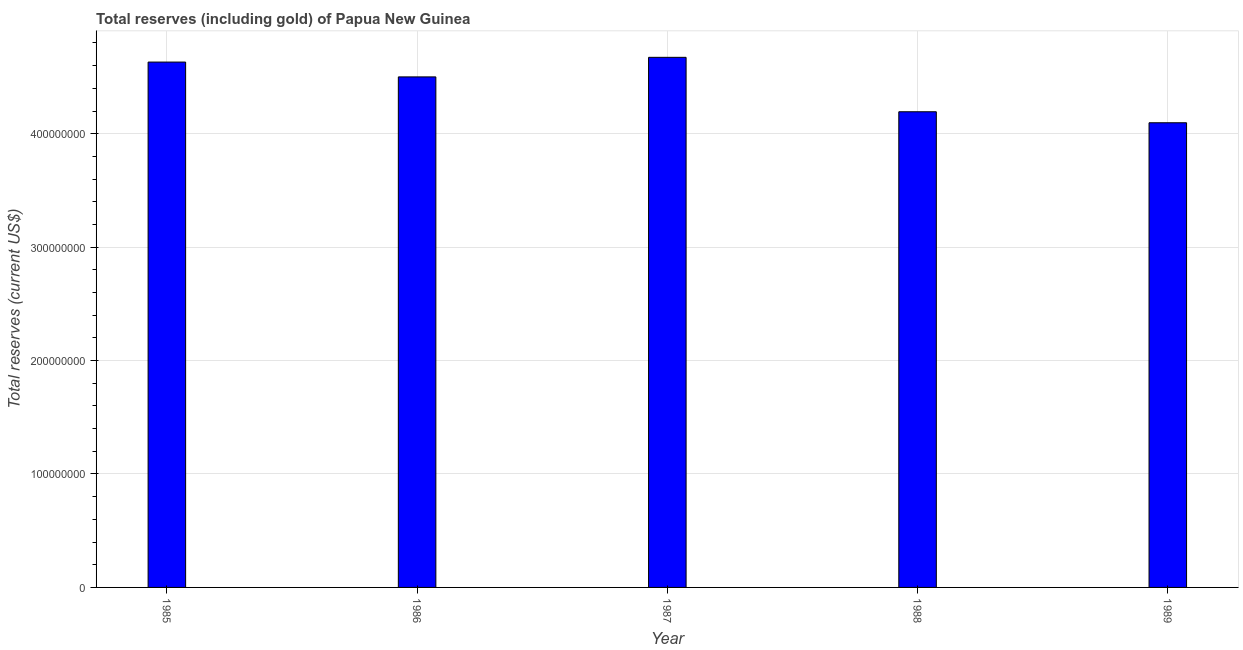Does the graph contain grids?
Offer a very short reply. Yes. What is the title of the graph?
Make the answer very short. Total reserves (including gold) of Papua New Guinea. What is the label or title of the Y-axis?
Give a very brief answer. Total reserves (current US$). What is the total reserves (including gold) in 1986?
Provide a short and direct response. 4.50e+08. Across all years, what is the maximum total reserves (including gold)?
Offer a very short reply. 4.67e+08. Across all years, what is the minimum total reserves (including gold)?
Your answer should be compact. 4.10e+08. What is the sum of the total reserves (including gold)?
Offer a terse response. 2.21e+09. What is the difference between the total reserves (including gold) in 1986 and 1988?
Make the answer very short. 3.07e+07. What is the average total reserves (including gold) per year?
Provide a succinct answer. 4.42e+08. What is the median total reserves (including gold)?
Your response must be concise. 4.50e+08. In how many years, is the total reserves (including gold) greater than 280000000 US$?
Provide a succinct answer. 5. Do a majority of the years between 1988 and 1989 (inclusive) have total reserves (including gold) greater than 120000000 US$?
Provide a short and direct response. Yes. What is the ratio of the total reserves (including gold) in 1987 to that in 1989?
Your answer should be very brief. 1.14. Is the total reserves (including gold) in 1986 less than that in 1989?
Provide a succinct answer. No. What is the difference between the highest and the second highest total reserves (including gold)?
Make the answer very short. 4.18e+06. What is the difference between the highest and the lowest total reserves (including gold)?
Make the answer very short. 5.77e+07. In how many years, is the total reserves (including gold) greater than the average total reserves (including gold) taken over all years?
Give a very brief answer. 3. How many bars are there?
Your answer should be very brief. 5. How many years are there in the graph?
Your response must be concise. 5. Are the values on the major ticks of Y-axis written in scientific E-notation?
Give a very brief answer. No. What is the Total reserves (current US$) of 1985?
Offer a terse response. 4.63e+08. What is the Total reserves (current US$) in 1986?
Provide a short and direct response. 4.50e+08. What is the Total reserves (current US$) of 1987?
Offer a very short reply. 4.67e+08. What is the Total reserves (current US$) in 1988?
Offer a terse response. 4.19e+08. What is the Total reserves (current US$) in 1989?
Your answer should be compact. 4.10e+08. What is the difference between the Total reserves (current US$) in 1985 and 1986?
Your answer should be compact. 1.31e+07. What is the difference between the Total reserves (current US$) in 1985 and 1987?
Ensure brevity in your answer.  -4.18e+06. What is the difference between the Total reserves (current US$) in 1985 and 1988?
Ensure brevity in your answer.  4.38e+07. What is the difference between the Total reserves (current US$) in 1985 and 1989?
Offer a very short reply. 5.35e+07. What is the difference between the Total reserves (current US$) in 1986 and 1987?
Provide a short and direct response. -1.73e+07. What is the difference between the Total reserves (current US$) in 1986 and 1988?
Make the answer very short. 3.07e+07. What is the difference between the Total reserves (current US$) in 1986 and 1989?
Ensure brevity in your answer.  4.04e+07. What is the difference between the Total reserves (current US$) in 1987 and 1988?
Offer a terse response. 4.80e+07. What is the difference between the Total reserves (current US$) in 1987 and 1989?
Make the answer very short. 5.77e+07. What is the difference between the Total reserves (current US$) in 1988 and 1989?
Offer a terse response. 9.69e+06. What is the ratio of the Total reserves (current US$) in 1985 to that in 1986?
Ensure brevity in your answer.  1.03. What is the ratio of the Total reserves (current US$) in 1985 to that in 1988?
Keep it short and to the point. 1.1. What is the ratio of the Total reserves (current US$) in 1985 to that in 1989?
Provide a short and direct response. 1.13. What is the ratio of the Total reserves (current US$) in 1986 to that in 1987?
Provide a succinct answer. 0.96. What is the ratio of the Total reserves (current US$) in 1986 to that in 1988?
Offer a terse response. 1.07. What is the ratio of the Total reserves (current US$) in 1986 to that in 1989?
Your answer should be very brief. 1.1. What is the ratio of the Total reserves (current US$) in 1987 to that in 1988?
Your response must be concise. 1.11. What is the ratio of the Total reserves (current US$) in 1987 to that in 1989?
Offer a very short reply. 1.14. 